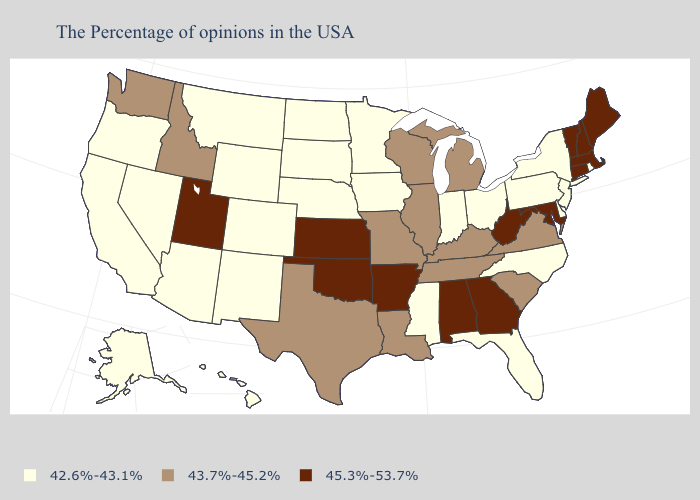Among the states that border Pennsylvania , which have the lowest value?
Quick response, please. New York, New Jersey, Delaware, Ohio. Does Missouri have the lowest value in the USA?
Write a very short answer. No. Does Montana have the same value as Colorado?
Keep it brief. Yes. Name the states that have a value in the range 42.6%-43.1%?
Short answer required. Rhode Island, New York, New Jersey, Delaware, Pennsylvania, North Carolina, Ohio, Florida, Indiana, Mississippi, Minnesota, Iowa, Nebraska, South Dakota, North Dakota, Wyoming, Colorado, New Mexico, Montana, Arizona, Nevada, California, Oregon, Alaska, Hawaii. Name the states that have a value in the range 43.7%-45.2%?
Keep it brief. Virginia, South Carolina, Michigan, Kentucky, Tennessee, Wisconsin, Illinois, Louisiana, Missouri, Texas, Idaho, Washington. Name the states that have a value in the range 45.3%-53.7%?
Be succinct. Maine, Massachusetts, New Hampshire, Vermont, Connecticut, Maryland, West Virginia, Georgia, Alabama, Arkansas, Kansas, Oklahoma, Utah. Does Wyoming have the lowest value in the USA?
Quick response, please. Yes. Which states have the highest value in the USA?
Keep it brief. Maine, Massachusetts, New Hampshire, Vermont, Connecticut, Maryland, West Virginia, Georgia, Alabama, Arkansas, Kansas, Oklahoma, Utah. Does Minnesota have a higher value than Florida?
Give a very brief answer. No. Does Tennessee have the highest value in the USA?
Concise answer only. No. Among the states that border New York , does New Jersey have the highest value?
Concise answer only. No. Name the states that have a value in the range 42.6%-43.1%?
Be succinct. Rhode Island, New York, New Jersey, Delaware, Pennsylvania, North Carolina, Ohio, Florida, Indiana, Mississippi, Minnesota, Iowa, Nebraska, South Dakota, North Dakota, Wyoming, Colorado, New Mexico, Montana, Arizona, Nevada, California, Oregon, Alaska, Hawaii. Among the states that border Vermont , which have the lowest value?
Concise answer only. New York. What is the value of Connecticut?
Quick response, please. 45.3%-53.7%. What is the value of Wyoming?
Write a very short answer. 42.6%-43.1%. 